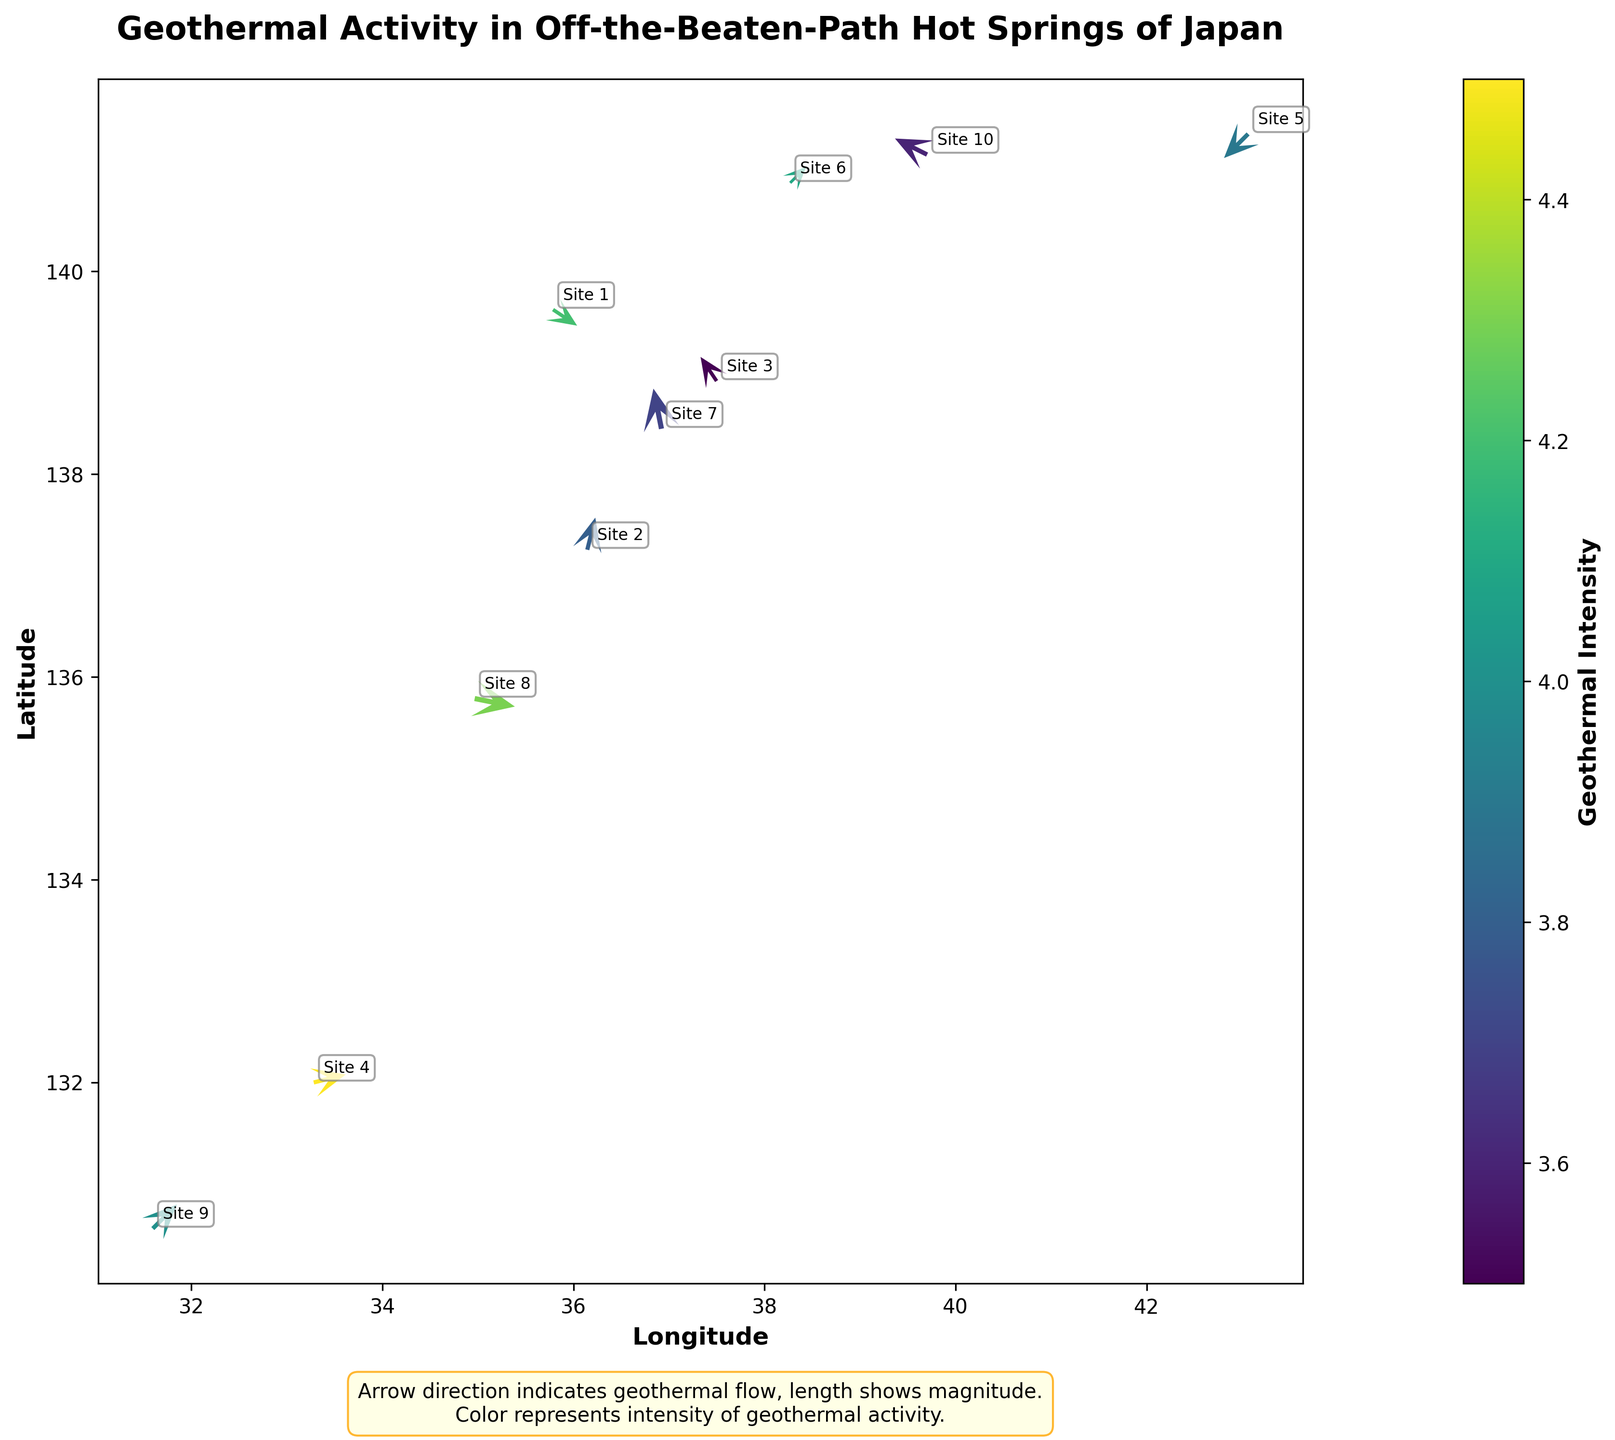What's the title of the figure? The title is located at the top of the figure and provides a summary of what the plot is about, which is usually very clearly visible.
Answer: Geothermal Activity in Off-the-Beaten-Path Hot Springs of Japan How is the direction of geothermal flow represented in the figure? The direction of geothermal flow is shown by the direction of the arrows in the quiver plot.
Answer: Arrow direction What does the color of the arrows indicate? The color of the arrows represents the intensity of geothermal activity, which is indicated by the color bar on the side of the plot.
Answer: Geothermal Intensity Which site has the highest geothermal intensity? Look for the arrow with the brightest color as intensity is represented by color according to the color bar legend. The arrow near coordinates (33.2814, 131.9984) is the brightest.
Answer: Site 4 What are the longitude and latitude ranges in the plot? Longitude is displayed on the X-axis and ranges from approximately 31.6 to 43 while latitude is shown on the Y-axis and ranges from approximately 130.5 to 141.3, as indicated by the tick marks on the axes.
Answer: Longitude: 31.6 to 43, Latitude: 130.5 to 141.3 Which site is located at the highest latitude? The site with the highest latitude will be the one farthest to the north on the Y-axis.
Answer: Site 5 Compare the geothermal flow at Site 1 and Site 9. Which site has a stronger flow in terms of magnitude? To determine the magnitude of the flow, look at the length of the arrows. The longer the arrow, the stronger the magnitude. Site 1's arrow length looks shorter compared to Site 9.
Answer: Site 9 What is the general trend in the direction of geothermal flow for sites in eastern Japan versus western Japan? Observe the direction of the arrows in the eastern part (right side) of the plot compared to the western part (left side). Eastern arrows (e.g., Site 6) point in various directions while western arrows (e.g., Site 4) generally point eastward.
Answer: Eastern Japan: various directions, Western Japan: eastward What is the general explanation provided in the figure about arrows and color? The text annotation in the plot explains that the arrow direction indicates geothermal flow, length shows magnitude, and the color represents intensity of geothermal activity.
Answer: Arrow direction indicates geothermal flow, length shows magnitude, color represents intensity What can you infer about the geothermal activity in northern Japan compared to southern Japan based on the plot? Compare the arrow directions, lengths, and colors from sites in northern Japan (like Site 5) with those in southern Japan (like Site 9). In northern Japan, the flows appear less intense (shorter arrows, darker colors), while southern sites have longer arrows and brighter colors indicating higher intensity activities.
Answer: Northern Japan: less intense, Southern Japan: more intense 